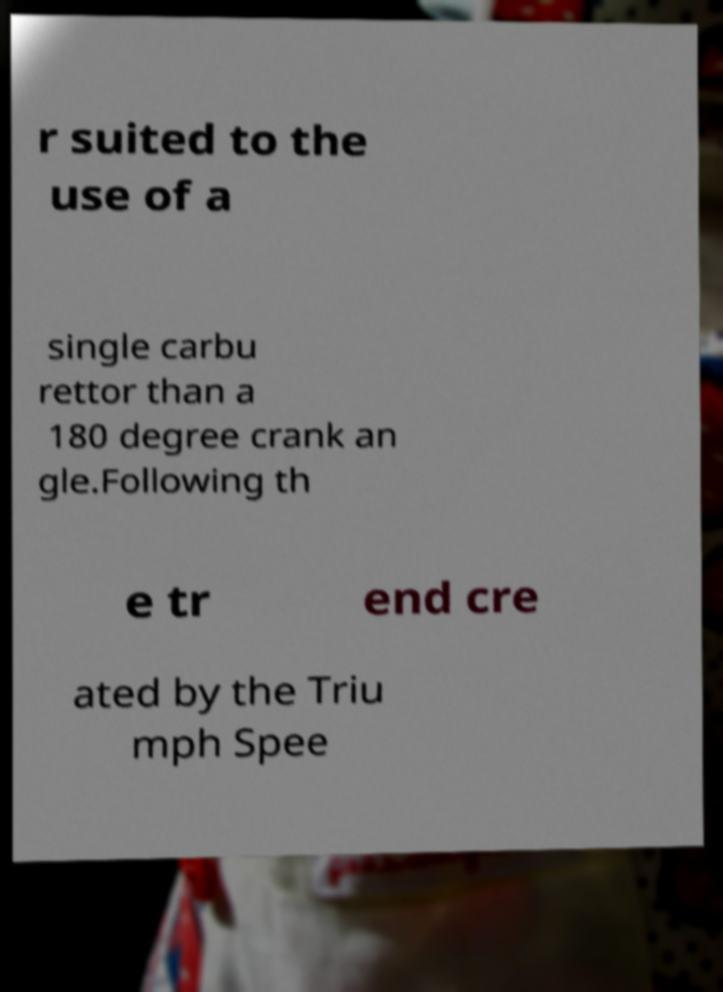Please identify and transcribe the text found in this image. r suited to the use of a single carbu rettor than a 180 degree crank an gle.Following th e tr end cre ated by the Triu mph Spee 